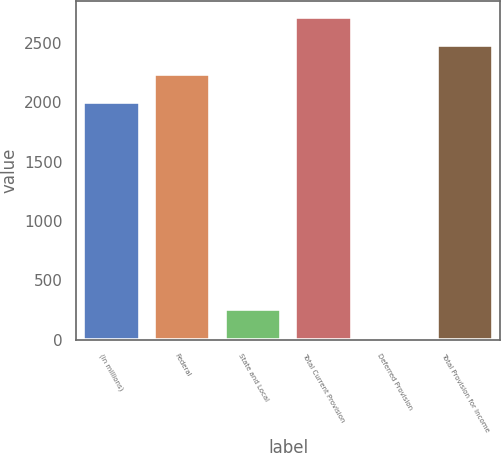<chart> <loc_0><loc_0><loc_500><loc_500><bar_chart><fcel>(in millions)<fcel>Federal<fcel>State and Local<fcel>Total Current Provision<fcel>Deferred Provision<fcel>Total Provision for Income<nl><fcel>2006<fcel>2242.9<fcel>261.9<fcel>2716.7<fcel>25<fcel>2479.8<nl></chart> 